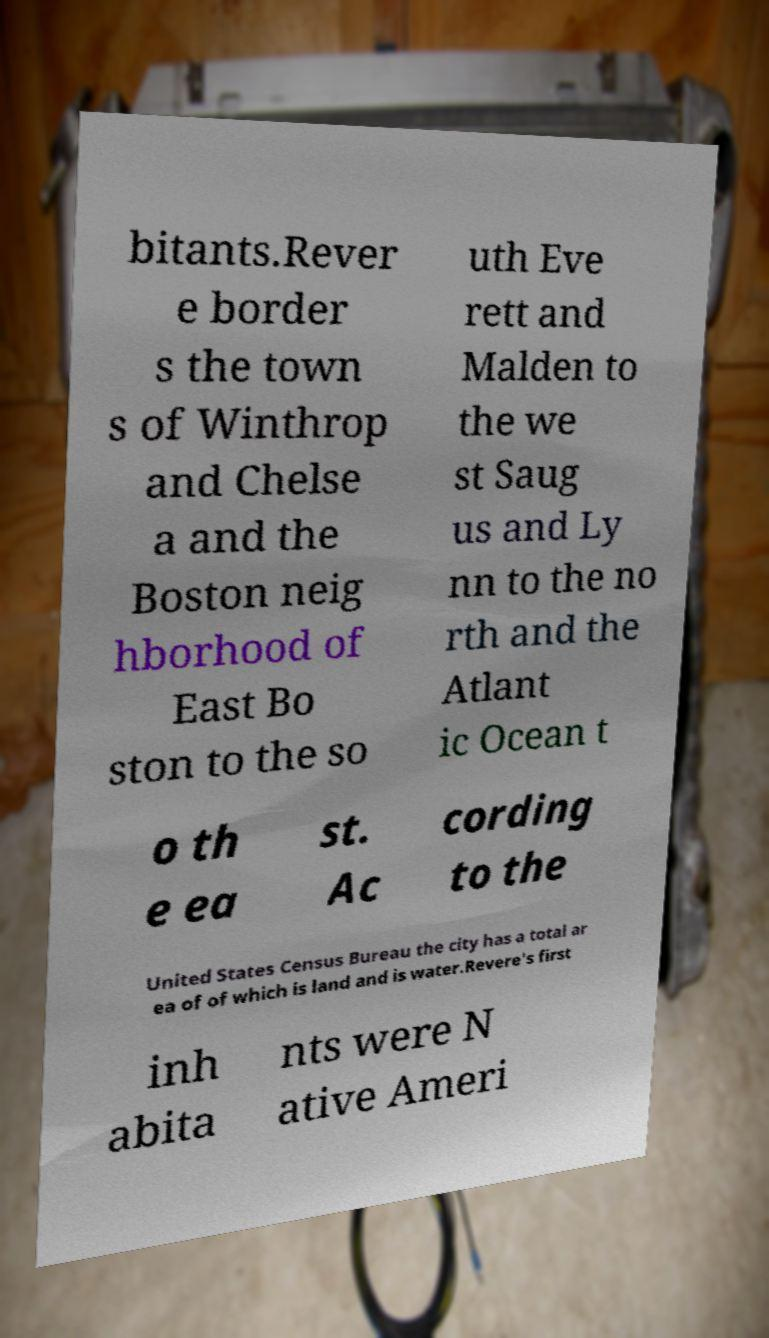For documentation purposes, I need the text within this image transcribed. Could you provide that? bitants.Rever e border s the town s of Winthrop and Chelse a and the Boston neig hborhood of East Bo ston to the so uth Eve rett and Malden to the we st Saug us and Ly nn to the no rth and the Atlant ic Ocean t o th e ea st. Ac cording to the United States Census Bureau the city has a total ar ea of of which is land and is water.Revere's first inh abita nts were N ative Ameri 